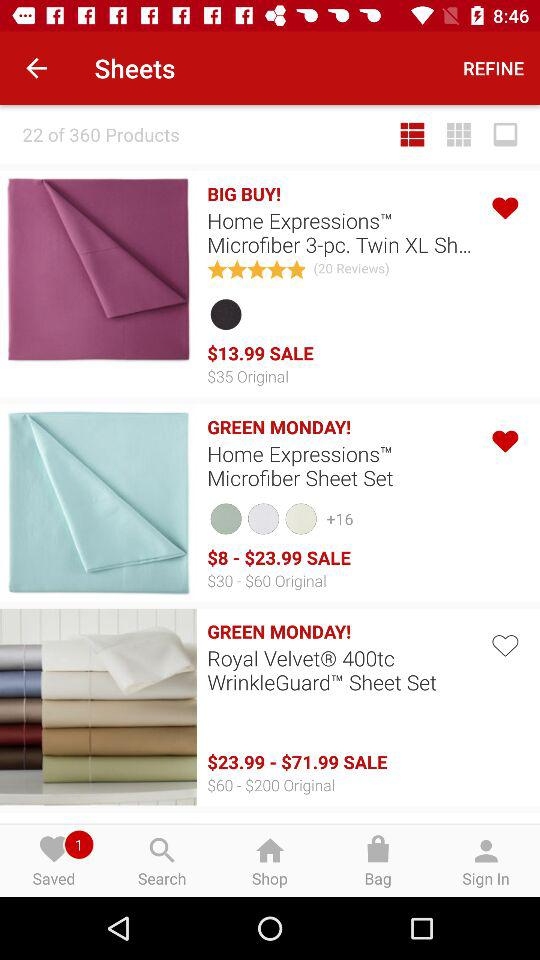How much is the most expensive item on sale?
Answer the question using a single word or phrase. $71.99 